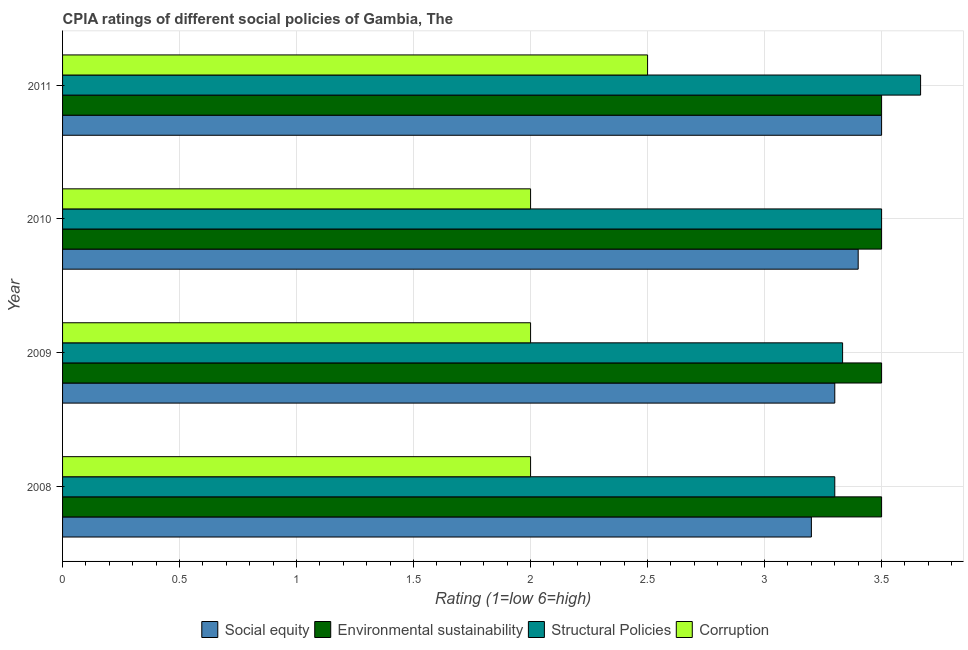How many different coloured bars are there?
Provide a short and direct response. 4. How many groups of bars are there?
Offer a terse response. 4. Are the number of bars per tick equal to the number of legend labels?
Ensure brevity in your answer.  Yes. Are the number of bars on each tick of the Y-axis equal?
Ensure brevity in your answer.  Yes. How many bars are there on the 3rd tick from the top?
Ensure brevity in your answer.  4. How many bars are there on the 2nd tick from the bottom?
Keep it short and to the point. 4. What is the cpia rating of environmental sustainability in 2009?
Give a very brief answer. 3.5. Across all years, what is the maximum cpia rating of social equity?
Ensure brevity in your answer.  3.5. In which year was the cpia rating of social equity minimum?
Your response must be concise. 2008. What is the difference between the cpia rating of corruption in 2010 and the cpia rating of social equity in 2008?
Offer a very short reply. -1.2. What is the average cpia rating of social equity per year?
Your answer should be compact. 3.35. In how many years, is the cpia rating of environmental sustainability greater than 3.2 ?
Ensure brevity in your answer.  4. What is the ratio of the cpia rating of social equity in 2009 to that in 2010?
Ensure brevity in your answer.  0.97. Is the cpia rating of corruption in 2008 less than that in 2011?
Your answer should be very brief. Yes. What is the difference between the highest and the lowest cpia rating of structural policies?
Provide a short and direct response. 0.37. Is it the case that in every year, the sum of the cpia rating of corruption and cpia rating of environmental sustainability is greater than the sum of cpia rating of social equity and cpia rating of structural policies?
Ensure brevity in your answer.  No. What does the 3rd bar from the top in 2008 represents?
Ensure brevity in your answer.  Environmental sustainability. What does the 4th bar from the bottom in 2008 represents?
Give a very brief answer. Corruption. Is it the case that in every year, the sum of the cpia rating of social equity and cpia rating of environmental sustainability is greater than the cpia rating of structural policies?
Give a very brief answer. Yes. How many years are there in the graph?
Your answer should be compact. 4. Are the values on the major ticks of X-axis written in scientific E-notation?
Keep it short and to the point. No. How are the legend labels stacked?
Your answer should be very brief. Horizontal. What is the title of the graph?
Your response must be concise. CPIA ratings of different social policies of Gambia, The. Does "Permission" appear as one of the legend labels in the graph?
Your answer should be compact. No. What is the Rating (1=low 6=high) in Social equity in 2008?
Provide a succinct answer. 3.2. What is the Rating (1=low 6=high) in Structural Policies in 2008?
Your answer should be very brief. 3.3. What is the Rating (1=low 6=high) in Social equity in 2009?
Your response must be concise. 3.3. What is the Rating (1=low 6=high) in Structural Policies in 2009?
Provide a succinct answer. 3.33. What is the Rating (1=low 6=high) in Social equity in 2010?
Keep it short and to the point. 3.4. What is the Rating (1=low 6=high) in Environmental sustainability in 2010?
Offer a terse response. 3.5. What is the Rating (1=low 6=high) in Social equity in 2011?
Offer a terse response. 3.5. What is the Rating (1=low 6=high) of Environmental sustainability in 2011?
Offer a very short reply. 3.5. What is the Rating (1=low 6=high) in Structural Policies in 2011?
Offer a very short reply. 3.67. What is the Rating (1=low 6=high) of Corruption in 2011?
Offer a terse response. 2.5. Across all years, what is the maximum Rating (1=low 6=high) in Social equity?
Offer a terse response. 3.5. Across all years, what is the maximum Rating (1=low 6=high) in Environmental sustainability?
Make the answer very short. 3.5. Across all years, what is the maximum Rating (1=low 6=high) of Structural Policies?
Offer a very short reply. 3.67. Across all years, what is the minimum Rating (1=low 6=high) of Social equity?
Offer a terse response. 3.2. Across all years, what is the minimum Rating (1=low 6=high) of Structural Policies?
Provide a succinct answer. 3.3. Across all years, what is the minimum Rating (1=low 6=high) in Corruption?
Provide a succinct answer. 2. What is the total Rating (1=low 6=high) in Social equity in the graph?
Give a very brief answer. 13.4. What is the total Rating (1=low 6=high) in Environmental sustainability in the graph?
Your response must be concise. 14. What is the total Rating (1=low 6=high) in Structural Policies in the graph?
Provide a succinct answer. 13.8. What is the difference between the Rating (1=low 6=high) of Social equity in 2008 and that in 2009?
Give a very brief answer. -0.1. What is the difference between the Rating (1=low 6=high) of Environmental sustainability in 2008 and that in 2009?
Your answer should be very brief. 0. What is the difference between the Rating (1=low 6=high) of Structural Policies in 2008 and that in 2009?
Keep it short and to the point. -0.03. What is the difference between the Rating (1=low 6=high) in Social equity in 2008 and that in 2010?
Offer a terse response. -0.2. What is the difference between the Rating (1=low 6=high) of Social equity in 2008 and that in 2011?
Keep it short and to the point. -0.3. What is the difference between the Rating (1=low 6=high) in Structural Policies in 2008 and that in 2011?
Give a very brief answer. -0.37. What is the difference between the Rating (1=low 6=high) in Corruption in 2008 and that in 2011?
Offer a terse response. -0.5. What is the difference between the Rating (1=low 6=high) of Social equity in 2009 and that in 2010?
Provide a short and direct response. -0.1. What is the difference between the Rating (1=low 6=high) of Corruption in 2009 and that in 2010?
Provide a short and direct response. 0. What is the difference between the Rating (1=low 6=high) of Social equity in 2009 and that in 2011?
Your answer should be very brief. -0.2. What is the difference between the Rating (1=low 6=high) in Structural Policies in 2009 and that in 2011?
Make the answer very short. -0.33. What is the difference between the Rating (1=low 6=high) in Environmental sustainability in 2010 and that in 2011?
Provide a succinct answer. 0. What is the difference between the Rating (1=low 6=high) in Structural Policies in 2010 and that in 2011?
Your answer should be very brief. -0.17. What is the difference between the Rating (1=low 6=high) of Corruption in 2010 and that in 2011?
Ensure brevity in your answer.  -0.5. What is the difference between the Rating (1=low 6=high) of Social equity in 2008 and the Rating (1=low 6=high) of Environmental sustainability in 2009?
Provide a short and direct response. -0.3. What is the difference between the Rating (1=low 6=high) in Social equity in 2008 and the Rating (1=low 6=high) in Structural Policies in 2009?
Ensure brevity in your answer.  -0.13. What is the difference between the Rating (1=low 6=high) in Environmental sustainability in 2008 and the Rating (1=low 6=high) in Corruption in 2009?
Make the answer very short. 1.5. What is the difference between the Rating (1=low 6=high) of Structural Policies in 2008 and the Rating (1=low 6=high) of Corruption in 2009?
Provide a short and direct response. 1.3. What is the difference between the Rating (1=low 6=high) in Social equity in 2008 and the Rating (1=low 6=high) in Structural Policies in 2010?
Ensure brevity in your answer.  -0.3. What is the difference between the Rating (1=low 6=high) of Environmental sustainability in 2008 and the Rating (1=low 6=high) of Corruption in 2010?
Keep it short and to the point. 1.5. What is the difference between the Rating (1=low 6=high) in Structural Policies in 2008 and the Rating (1=low 6=high) in Corruption in 2010?
Offer a terse response. 1.3. What is the difference between the Rating (1=low 6=high) in Social equity in 2008 and the Rating (1=low 6=high) in Environmental sustainability in 2011?
Offer a terse response. -0.3. What is the difference between the Rating (1=low 6=high) of Social equity in 2008 and the Rating (1=low 6=high) of Structural Policies in 2011?
Provide a succinct answer. -0.47. What is the difference between the Rating (1=low 6=high) in Social equity in 2008 and the Rating (1=low 6=high) in Corruption in 2011?
Offer a terse response. 0.7. What is the difference between the Rating (1=low 6=high) of Environmental sustainability in 2008 and the Rating (1=low 6=high) of Structural Policies in 2011?
Provide a succinct answer. -0.17. What is the difference between the Rating (1=low 6=high) of Environmental sustainability in 2008 and the Rating (1=low 6=high) of Corruption in 2011?
Make the answer very short. 1. What is the difference between the Rating (1=low 6=high) in Structural Policies in 2008 and the Rating (1=low 6=high) in Corruption in 2011?
Keep it short and to the point. 0.8. What is the difference between the Rating (1=low 6=high) of Social equity in 2009 and the Rating (1=low 6=high) of Environmental sustainability in 2010?
Your response must be concise. -0.2. What is the difference between the Rating (1=low 6=high) in Social equity in 2009 and the Rating (1=low 6=high) in Structural Policies in 2010?
Your answer should be compact. -0.2. What is the difference between the Rating (1=low 6=high) of Environmental sustainability in 2009 and the Rating (1=low 6=high) of Structural Policies in 2010?
Keep it short and to the point. 0. What is the difference between the Rating (1=low 6=high) of Environmental sustainability in 2009 and the Rating (1=low 6=high) of Corruption in 2010?
Keep it short and to the point. 1.5. What is the difference between the Rating (1=low 6=high) in Structural Policies in 2009 and the Rating (1=low 6=high) in Corruption in 2010?
Your answer should be very brief. 1.33. What is the difference between the Rating (1=low 6=high) of Social equity in 2009 and the Rating (1=low 6=high) of Structural Policies in 2011?
Your answer should be very brief. -0.37. What is the difference between the Rating (1=low 6=high) in Structural Policies in 2009 and the Rating (1=low 6=high) in Corruption in 2011?
Provide a short and direct response. 0.83. What is the difference between the Rating (1=low 6=high) in Social equity in 2010 and the Rating (1=low 6=high) in Environmental sustainability in 2011?
Your answer should be very brief. -0.1. What is the difference between the Rating (1=low 6=high) in Social equity in 2010 and the Rating (1=low 6=high) in Structural Policies in 2011?
Your answer should be compact. -0.27. What is the difference between the Rating (1=low 6=high) of Environmental sustainability in 2010 and the Rating (1=low 6=high) of Corruption in 2011?
Make the answer very short. 1. What is the difference between the Rating (1=low 6=high) in Structural Policies in 2010 and the Rating (1=low 6=high) in Corruption in 2011?
Your answer should be compact. 1. What is the average Rating (1=low 6=high) of Social equity per year?
Your answer should be very brief. 3.35. What is the average Rating (1=low 6=high) in Environmental sustainability per year?
Give a very brief answer. 3.5. What is the average Rating (1=low 6=high) in Structural Policies per year?
Offer a very short reply. 3.45. What is the average Rating (1=low 6=high) in Corruption per year?
Make the answer very short. 2.12. In the year 2008, what is the difference between the Rating (1=low 6=high) of Social equity and Rating (1=low 6=high) of Corruption?
Provide a succinct answer. 1.2. In the year 2008, what is the difference between the Rating (1=low 6=high) in Environmental sustainability and Rating (1=low 6=high) in Corruption?
Your response must be concise. 1.5. In the year 2009, what is the difference between the Rating (1=low 6=high) in Social equity and Rating (1=low 6=high) in Structural Policies?
Ensure brevity in your answer.  -0.03. In the year 2009, what is the difference between the Rating (1=low 6=high) of Social equity and Rating (1=low 6=high) of Corruption?
Provide a succinct answer. 1.3. In the year 2009, what is the difference between the Rating (1=low 6=high) of Environmental sustainability and Rating (1=low 6=high) of Structural Policies?
Offer a terse response. 0.17. In the year 2009, what is the difference between the Rating (1=low 6=high) in Structural Policies and Rating (1=low 6=high) in Corruption?
Offer a terse response. 1.33. In the year 2010, what is the difference between the Rating (1=low 6=high) of Social equity and Rating (1=low 6=high) of Environmental sustainability?
Offer a very short reply. -0.1. In the year 2010, what is the difference between the Rating (1=low 6=high) in Social equity and Rating (1=low 6=high) in Structural Policies?
Your response must be concise. -0.1. In the year 2010, what is the difference between the Rating (1=low 6=high) in Environmental sustainability and Rating (1=low 6=high) in Corruption?
Your answer should be very brief. 1.5. In the year 2011, what is the difference between the Rating (1=low 6=high) in Social equity and Rating (1=low 6=high) in Environmental sustainability?
Give a very brief answer. 0. In the year 2011, what is the difference between the Rating (1=low 6=high) in Environmental sustainability and Rating (1=low 6=high) in Corruption?
Offer a very short reply. 1. In the year 2011, what is the difference between the Rating (1=low 6=high) of Structural Policies and Rating (1=low 6=high) of Corruption?
Your answer should be compact. 1.17. What is the ratio of the Rating (1=low 6=high) of Social equity in 2008 to that in 2009?
Offer a terse response. 0.97. What is the ratio of the Rating (1=low 6=high) in Structural Policies in 2008 to that in 2009?
Offer a very short reply. 0.99. What is the ratio of the Rating (1=low 6=high) in Corruption in 2008 to that in 2009?
Offer a very short reply. 1. What is the ratio of the Rating (1=low 6=high) of Environmental sustainability in 2008 to that in 2010?
Offer a very short reply. 1. What is the ratio of the Rating (1=low 6=high) of Structural Policies in 2008 to that in 2010?
Ensure brevity in your answer.  0.94. What is the ratio of the Rating (1=low 6=high) in Social equity in 2008 to that in 2011?
Make the answer very short. 0.91. What is the ratio of the Rating (1=low 6=high) in Environmental sustainability in 2008 to that in 2011?
Give a very brief answer. 1. What is the ratio of the Rating (1=low 6=high) in Structural Policies in 2008 to that in 2011?
Provide a succinct answer. 0.9. What is the ratio of the Rating (1=low 6=high) of Social equity in 2009 to that in 2010?
Make the answer very short. 0.97. What is the ratio of the Rating (1=low 6=high) of Environmental sustainability in 2009 to that in 2010?
Provide a short and direct response. 1. What is the ratio of the Rating (1=low 6=high) of Social equity in 2009 to that in 2011?
Give a very brief answer. 0.94. What is the ratio of the Rating (1=low 6=high) of Structural Policies in 2009 to that in 2011?
Ensure brevity in your answer.  0.91. What is the ratio of the Rating (1=low 6=high) of Corruption in 2009 to that in 2011?
Your answer should be very brief. 0.8. What is the ratio of the Rating (1=low 6=high) of Social equity in 2010 to that in 2011?
Offer a terse response. 0.97. What is the ratio of the Rating (1=low 6=high) in Structural Policies in 2010 to that in 2011?
Keep it short and to the point. 0.95. What is the ratio of the Rating (1=low 6=high) of Corruption in 2010 to that in 2011?
Make the answer very short. 0.8. What is the difference between the highest and the second highest Rating (1=low 6=high) of Social equity?
Provide a short and direct response. 0.1. What is the difference between the highest and the second highest Rating (1=low 6=high) of Structural Policies?
Ensure brevity in your answer.  0.17. What is the difference between the highest and the lowest Rating (1=low 6=high) of Social equity?
Provide a short and direct response. 0.3. What is the difference between the highest and the lowest Rating (1=low 6=high) of Structural Policies?
Provide a succinct answer. 0.37. 